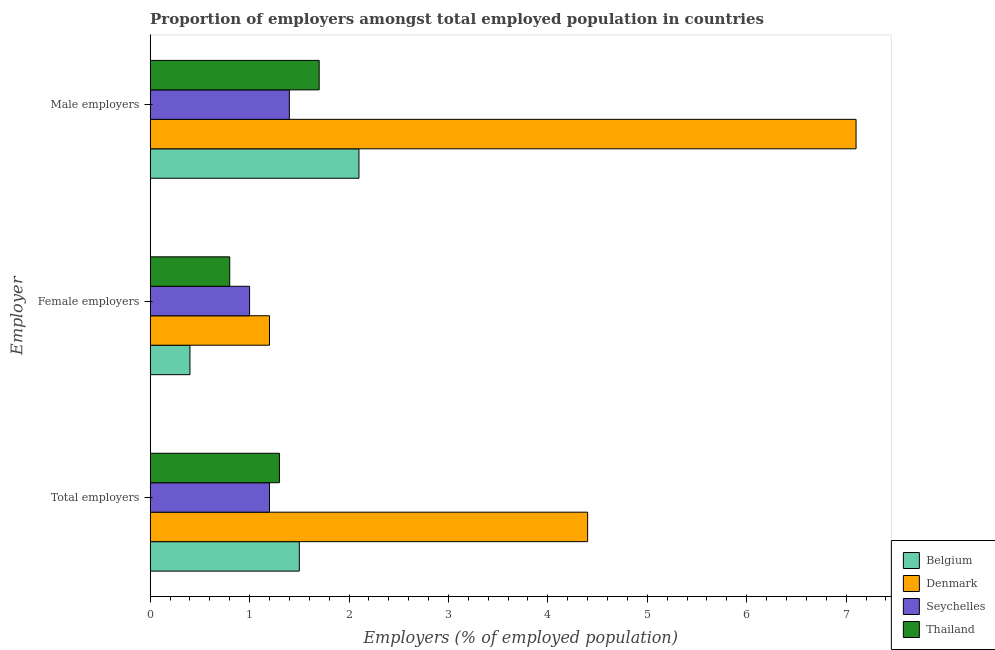How many different coloured bars are there?
Provide a succinct answer. 4. Are the number of bars per tick equal to the number of legend labels?
Provide a succinct answer. Yes. What is the label of the 3rd group of bars from the top?
Offer a terse response. Total employers. What is the percentage of female employers in Belgium?
Provide a short and direct response. 0.4. Across all countries, what is the maximum percentage of female employers?
Your answer should be compact. 1.2. Across all countries, what is the minimum percentage of total employers?
Offer a terse response. 1.2. What is the total percentage of female employers in the graph?
Your answer should be compact. 3.4. What is the difference between the percentage of female employers in Belgium and that in Seychelles?
Provide a succinct answer. -0.6. What is the difference between the percentage of total employers in Seychelles and the percentage of male employers in Denmark?
Your answer should be very brief. -5.9. What is the average percentage of total employers per country?
Keep it short and to the point. 2.1. What is the difference between the percentage of male employers and percentage of total employers in Thailand?
Offer a very short reply. 0.4. What is the ratio of the percentage of total employers in Seychelles to that in Denmark?
Offer a terse response. 0.27. Is the difference between the percentage of male employers in Thailand and Seychelles greater than the difference between the percentage of female employers in Thailand and Seychelles?
Make the answer very short. Yes. What is the difference between the highest and the second highest percentage of female employers?
Give a very brief answer. 0.2. What is the difference between the highest and the lowest percentage of male employers?
Ensure brevity in your answer.  5.7. Is the sum of the percentage of female employers in Denmark and Belgium greater than the maximum percentage of total employers across all countries?
Your response must be concise. No. What does the 2nd bar from the top in Female employers represents?
Offer a terse response. Seychelles. What does the 1st bar from the bottom in Female employers represents?
Give a very brief answer. Belgium. How many countries are there in the graph?
Offer a terse response. 4. What is the difference between two consecutive major ticks on the X-axis?
Your answer should be very brief. 1. Are the values on the major ticks of X-axis written in scientific E-notation?
Offer a very short reply. No. Does the graph contain any zero values?
Ensure brevity in your answer.  No. What is the title of the graph?
Give a very brief answer. Proportion of employers amongst total employed population in countries. What is the label or title of the X-axis?
Keep it short and to the point. Employers (% of employed population). What is the label or title of the Y-axis?
Make the answer very short. Employer. What is the Employers (% of employed population) in Belgium in Total employers?
Offer a terse response. 1.5. What is the Employers (% of employed population) of Denmark in Total employers?
Your response must be concise. 4.4. What is the Employers (% of employed population) of Seychelles in Total employers?
Provide a succinct answer. 1.2. What is the Employers (% of employed population) in Thailand in Total employers?
Make the answer very short. 1.3. What is the Employers (% of employed population) of Belgium in Female employers?
Offer a very short reply. 0.4. What is the Employers (% of employed population) in Denmark in Female employers?
Offer a terse response. 1.2. What is the Employers (% of employed population) of Seychelles in Female employers?
Give a very brief answer. 1. What is the Employers (% of employed population) in Thailand in Female employers?
Give a very brief answer. 0.8. What is the Employers (% of employed population) of Belgium in Male employers?
Provide a short and direct response. 2.1. What is the Employers (% of employed population) of Denmark in Male employers?
Ensure brevity in your answer.  7.1. What is the Employers (% of employed population) of Seychelles in Male employers?
Offer a very short reply. 1.4. What is the Employers (% of employed population) in Thailand in Male employers?
Keep it short and to the point. 1.7. Across all Employer, what is the maximum Employers (% of employed population) of Belgium?
Your answer should be very brief. 2.1. Across all Employer, what is the maximum Employers (% of employed population) in Denmark?
Your answer should be very brief. 7.1. Across all Employer, what is the maximum Employers (% of employed population) of Seychelles?
Give a very brief answer. 1.4. Across all Employer, what is the maximum Employers (% of employed population) of Thailand?
Offer a terse response. 1.7. Across all Employer, what is the minimum Employers (% of employed population) of Belgium?
Keep it short and to the point. 0.4. Across all Employer, what is the minimum Employers (% of employed population) of Denmark?
Make the answer very short. 1.2. Across all Employer, what is the minimum Employers (% of employed population) in Seychelles?
Your answer should be very brief. 1. Across all Employer, what is the minimum Employers (% of employed population) in Thailand?
Make the answer very short. 0.8. What is the total Employers (% of employed population) of Belgium in the graph?
Offer a very short reply. 4. What is the difference between the Employers (% of employed population) in Belgium in Total employers and that in Female employers?
Make the answer very short. 1.1. What is the difference between the Employers (% of employed population) of Denmark in Total employers and that in Female employers?
Make the answer very short. 3.2. What is the difference between the Employers (% of employed population) of Belgium in Total employers and that in Male employers?
Keep it short and to the point. -0.6. What is the difference between the Employers (% of employed population) in Denmark in Total employers and that in Male employers?
Your answer should be very brief. -2.7. What is the difference between the Employers (% of employed population) of Denmark in Female employers and that in Male employers?
Offer a very short reply. -5.9. What is the difference between the Employers (% of employed population) in Thailand in Female employers and that in Male employers?
Provide a short and direct response. -0.9. What is the difference between the Employers (% of employed population) of Belgium in Total employers and the Employers (% of employed population) of Denmark in Female employers?
Your answer should be very brief. 0.3. What is the difference between the Employers (% of employed population) in Denmark in Total employers and the Employers (% of employed population) in Seychelles in Female employers?
Provide a short and direct response. 3.4. What is the difference between the Employers (% of employed population) of Denmark in Total employers and the Employers (% of employed population) of Thailand in Female employers?
Ensure brevity in your answer.  3.6. What is the difference between the Employers (% of employed population) in Belgium in Total employers and the Employers (% of employed population) in Seychelles in Male employers?
Provide a succinct answer. 0.1. What is the difference between the Employers (% of employed population) in Denmark in Total employers and the Employers (% of employed population) in Thailand in Male employers?
Provide a short and direct response. 2.7. What is the difference between the Employers (% of employed population) in Seychelles in Total employers and the Employers (% of employed population) in Thailand in Male employers?
Offer a terse response. -0.5. What is the difference between the Employers (% of employed population) in Belgium in Female employers and the Employers (% of employed population) in Seychelles in Male employers?
Keep it short and to the point. -1. What is the difference between the Employers (% of employed population) of Belgium in Female employers and the Employers (% of employed population) of Thailand in Male employers?
Your answer should be compact. -1.3. What is the difference between the Employers (% of employed population) of Denmark in Female employers and the Employers (% of employed population) of Thailand in Male employers?
Provide a short and direct response. -0.5. What is the difference between the Employers (% of employed population) in Seychelles in Female employers and the Employers (% of employed population) in Thailand in Male employers?
Ensure brevity in your answer.  -0.7. What is the average Employers (% of employed population) of Belgium per Employer?
Offer a very short reply. 1.33. What is the average Employers (% of employed population) of Denmark per Employer?
Your answer should be very brief. 4.23. What is the average Employers (% of employed population) of Seychelles per Employer?
Offer a terse response. 1.2. What is the average Employers (% of employed population) of Thailand per Employer?
Your response must be concise. 1.27. What is the difference between the Employers (% of employed population) in Belgium and Employers (% of employed population) in Denmark in Total employers?
Offer a terse response. -2.9. What is the difference between the Employers (% of employed population) of Belgium and Employers (% of employed population) of Thailand in Total employers?
Your answer should be very brief. 0.2. What is the difference between the Employers (% of employed population) in Denmark and Employers (% of employed population) in Thailand in Total employers?
Your answer should be very brief. 3.1. What is the difference between the Employers (% of employed population) of Seychelles and Employers (% of employed population) of Thailand in Total employers?
Provide a succinct answer. -0.1. What is the difference between the Employers (% of employed population) in Belgium and Employers (% of employed population) in Denmark in Female employers?
Your answer should be very brief. -0.8. What is the difference between the Employers (% of employed population) of Belgium and Employers (% of employed population) of Seychelles in Female employers?
Your response must be concise. -0.6. What is the difference between the Employers (% of employed population) of Belgium and Employers (% of employed population) of Thailand in Female employers?
Provide a short and direct response. -0.4. What is the difference between the Employers (% of employed population) of Seychelles and Employers (% of employed population) of Thailand in Female employers?
Your response must be concise. 0.2. What is the difference between the Employers (% of employed population) in Belgium and Employers (% of employed population) in Denmark in Male employers?
Make the answer very short. -5. What is the difference between the Employers (% of employed population) of Belgium and Employers (% of employed population) of Seychelles in Male employers?
Give a very brief answer. 0.7. What is the difference between the Employers (% of employed population) in Belgium and Employers (% of employed population) in Thailand in Male employers?
Ensure brevity in your answer.  0.4. What is the ratio of the Employers (% of employed population) of Belgium in Total employers to that in Female employers?
Your response must be concise. 3.75. What is the ratio of the Employers (% of employed population) in Denmark in Total employers to that in Female employers?
Your response must be concise. 3.67. What is the ratio of the Employers (% of employed population) in Thailand in Total employers to that in Female employers?
Provide a short and direct response. 1.62. What is the ratio of the Employers (% of employed population) in Belgium in Total employers to that in Male employers?
Your answer should be very brief. 0.71. What is the ratio of the Employers (% of employed population) of Denmark in Total employers to that in Male employers?
Your answer should be very brief. 0.62. What is the ratio of the Employers (% of employed population) of Thailand in Total employers to that in Male employers?
Give a very brief answer. 0.76. What is the ratio of the Employers (% of employed population) of Belgium in Female employers to that in Male employers?
Your answer should be very brief. 0.19. What is the ratio of the Employers (% of employed population) of Denmark in Female employers to that in Male employers?
Provide a short and direct response. 0.17. What is the ratio of the Employers (% of employed population) in Seychelles in Female employers to that in Male employers?
Give a very brief answer. 0.71. What is the ratio of the Employers (% of employed population) in Thailand in Female employers to that in Male employers?
Your answer should be very brief. 0.47. What is the difference between the highest and the second highest Employers (% of employed population) of Belgium?
Your answer should be compact. 0.6. What is the difference between the highest and the second highest Employers (% of employed population) of Seychelles?
Provide a short and direct response. 0.2. What is the difference between the highest and the second highest Employers (% of employed population) in Thailand?
Your answer should be very brief. 0.4. 